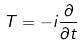<formula> <loc_0><loc_0><loc_500><loc_500>T = - i \frac { \partial } { \partial t }</formula> 